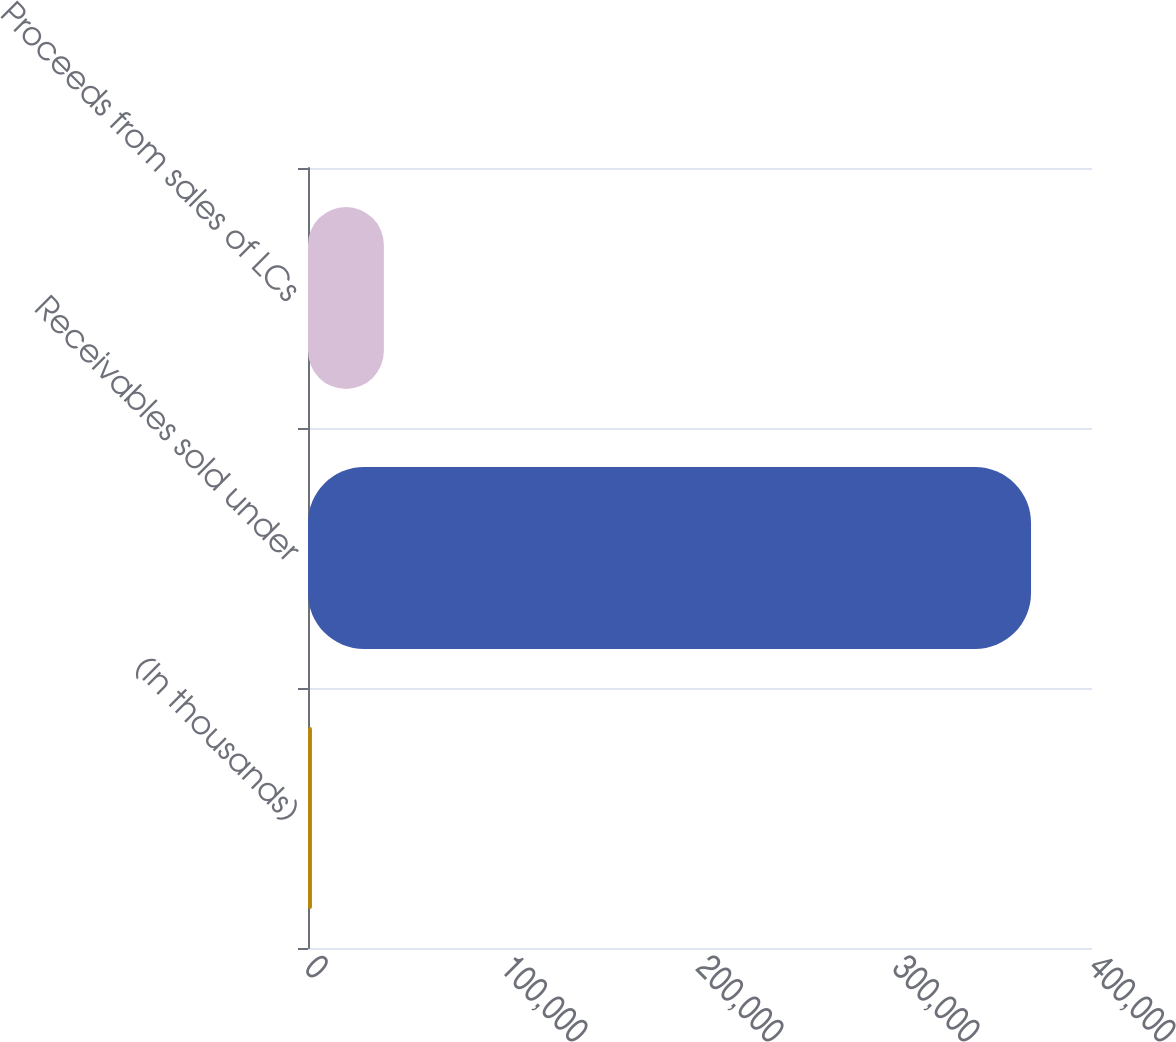<chart> <loc_0><loc_0><loc_500><loc_500><bar_chart><fcel>(In thousands)<fcel>Receivables sold under<fcel>Proceeds from sales of LCs<nl><fcel>2012<fcel>368894<fcel>38700.2<nl></chart> 